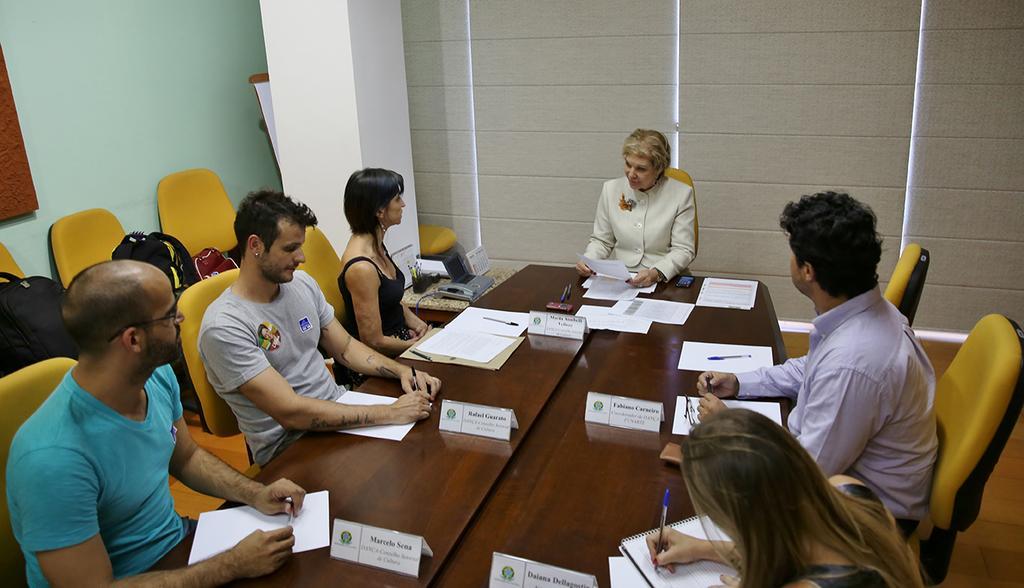How would you summarize this image in a sentence or two? Here we can see a woman sitting on a chair and she is speaking to this woman who was on the left side. Here we can see a four persons who are sitting on a chair and they are paying attention to this woman. 